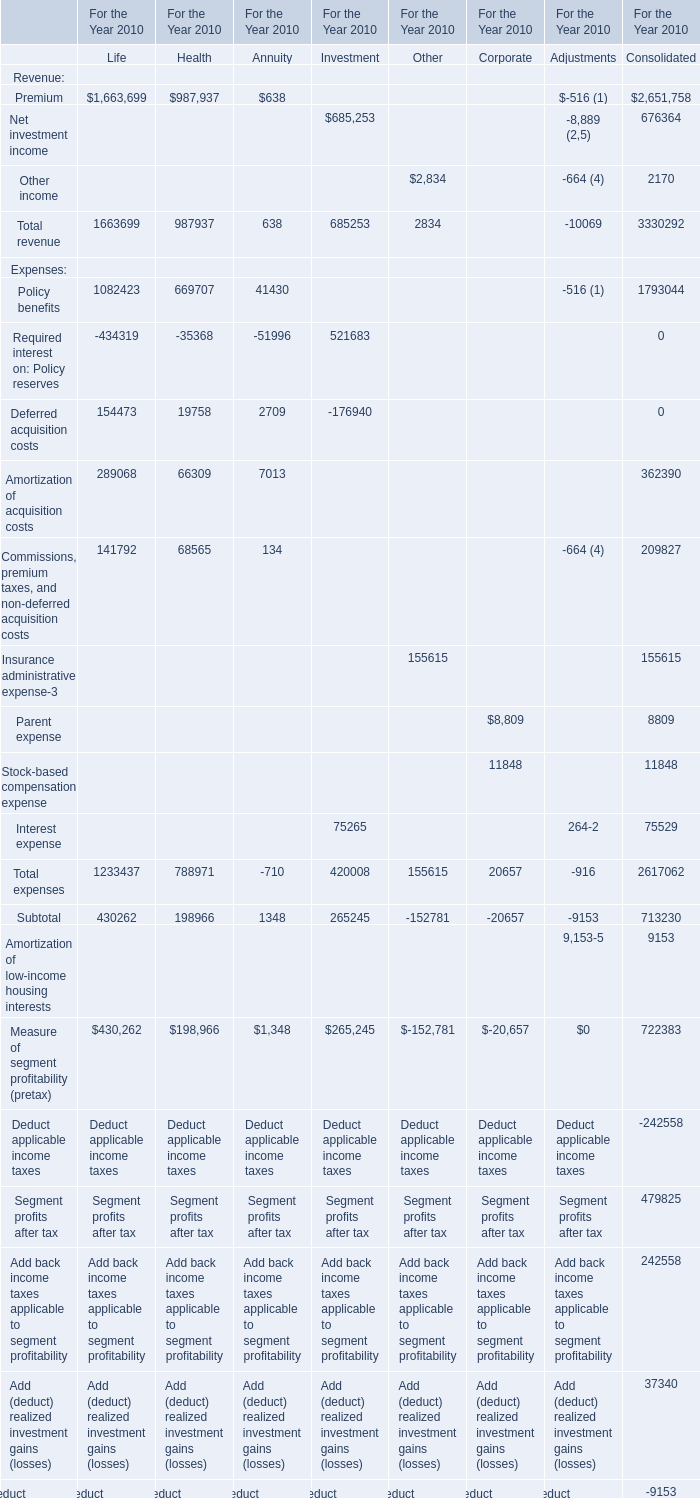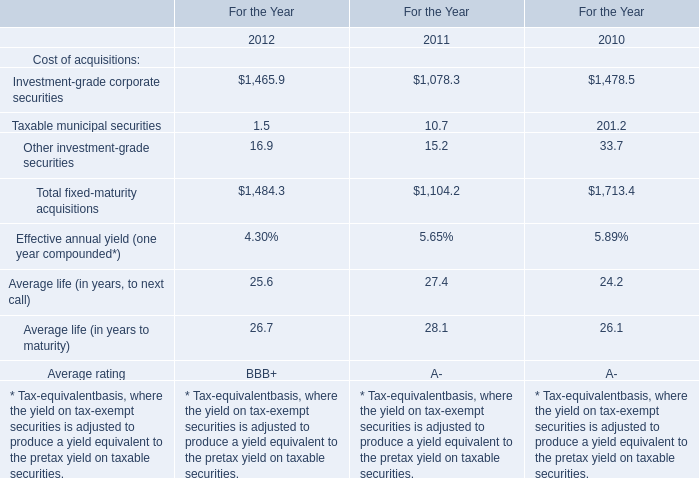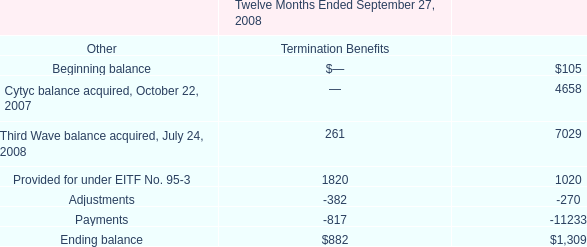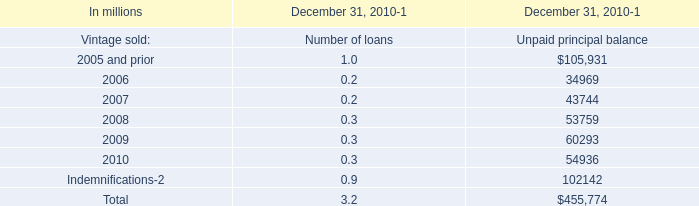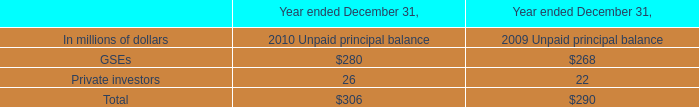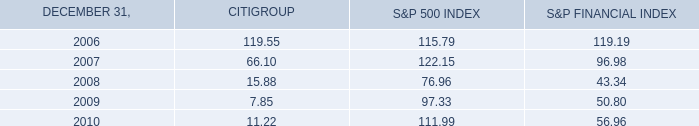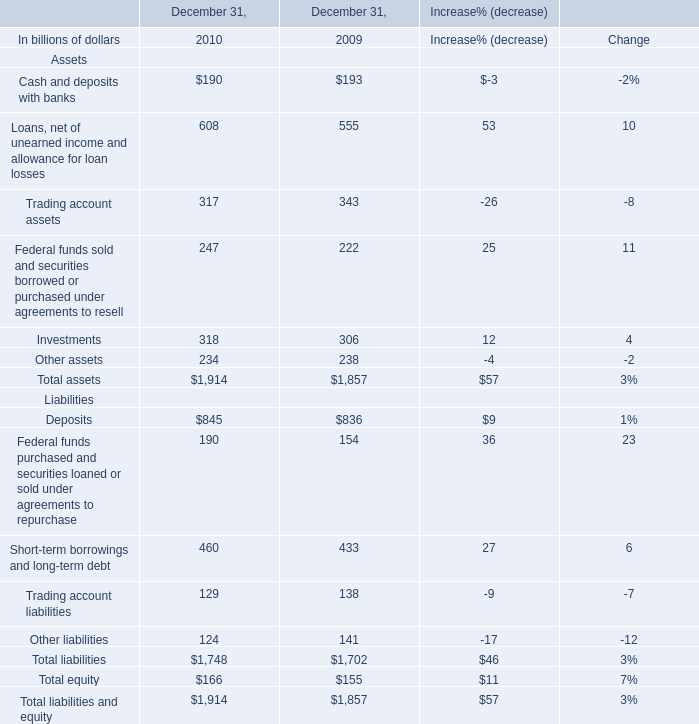Which year the Cash and deposits with banks is the highest? 
Answer: 2009. 